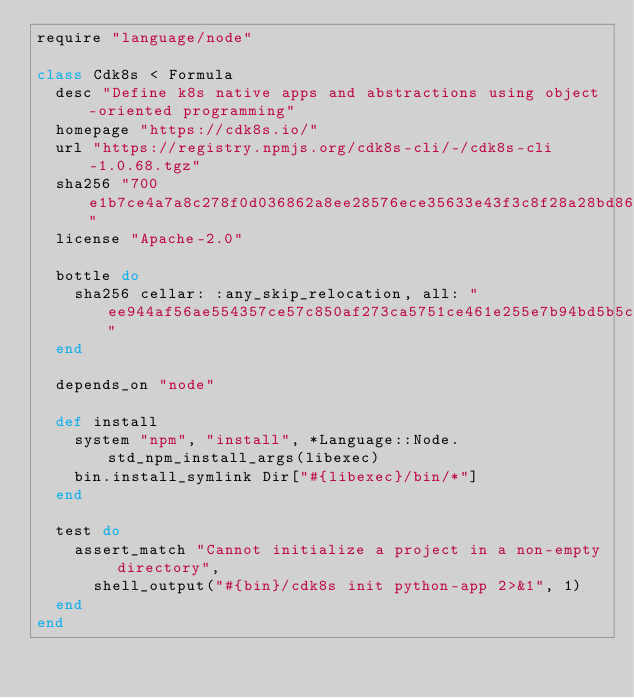Convert code to text. <code><loc_0><loc_0><loc_500><loc_500><_Ruby_>require "language/node"

class Cdk8s < Formula
  desc "Define k8s native apps and abstractions using object-oriented programming"
  homepage "https://cdk8s.io/"
  url "https://registry.npmjs.org/cdk8s-cli/-/cdk8s-cli-1.0.68.tgz"
  sha256 "700e1b7ce4a7a8c278f0d036862a8ee28576ece35633e43f3c8f28a28bd866e5"
  license "Apache-2.0"

  bottle do
    sha256 cellar: :any_skip_relocation, all: "ee944af56ae554357ce57c850af273ca5751ce461e255e7b94bd5b5c764ecab1"
  end

  depends_on "node"

  def install
    system "npm", "install", *Language::Node.std_npm_install_args(libexec)
    bin.install_symlink Dir["#{libexec}/bin/*"]
  end

  test do
    assert_match "Cannot initialize a project in a non-empty directory",
      shell_output("#{bin}/cdk8s init python-app 2>&1", 1)
  end
end
</code> 